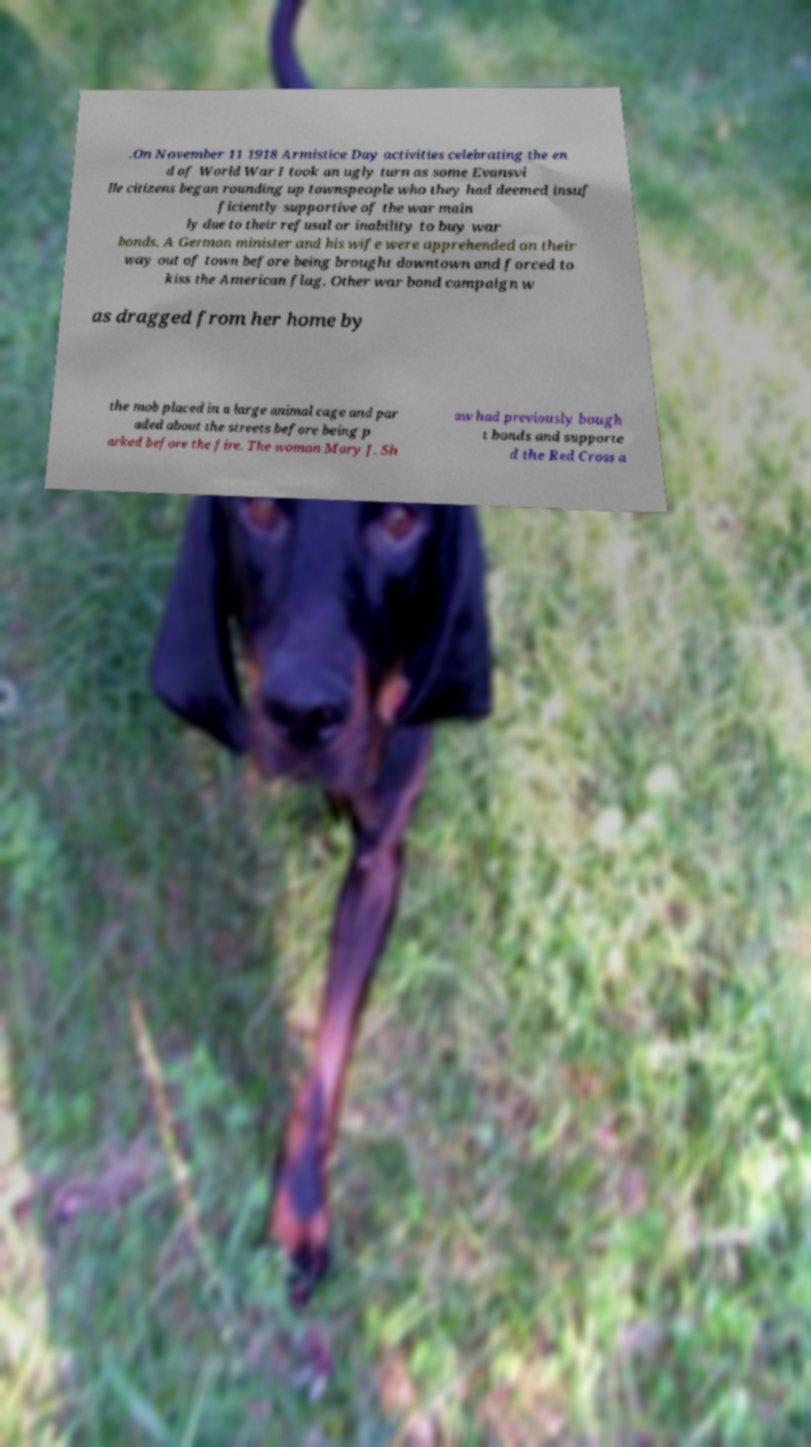There's text embedded in this image that I need extracted. Can you transcribe it verbatim? .On November 11 1918 Armistice Day activities celebrating the en d of World War I took an ugly turn as some Evansvi lle citizens began rounding up townspeople who they had deemed insuf ficiently supportive of the war main ly due to their refusal or inability to buy war bonds. A German minister and his wife were apprehended on their way out of town before being brought downtown and forced to kiss the American flag. Other war bond campaign w as dragged from her home by the mob placed in a large animal cage and par aded about the streets before being p arked before the fire. The woman Mary J. Sh aw had previously bough t bonds and supporte d the Red Cross a 